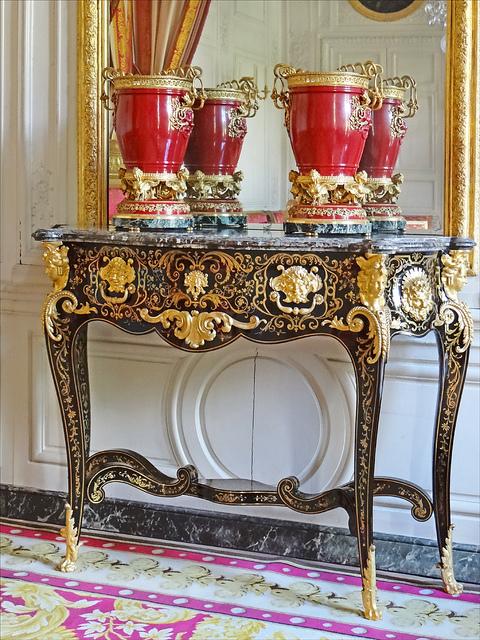Is this a modern furniture design?
Be succinct. No. Can you see the reflection of the red urns?
Give a very brief answer. Yes. Is this furniture expensive?
Answer briefly. Yes. 